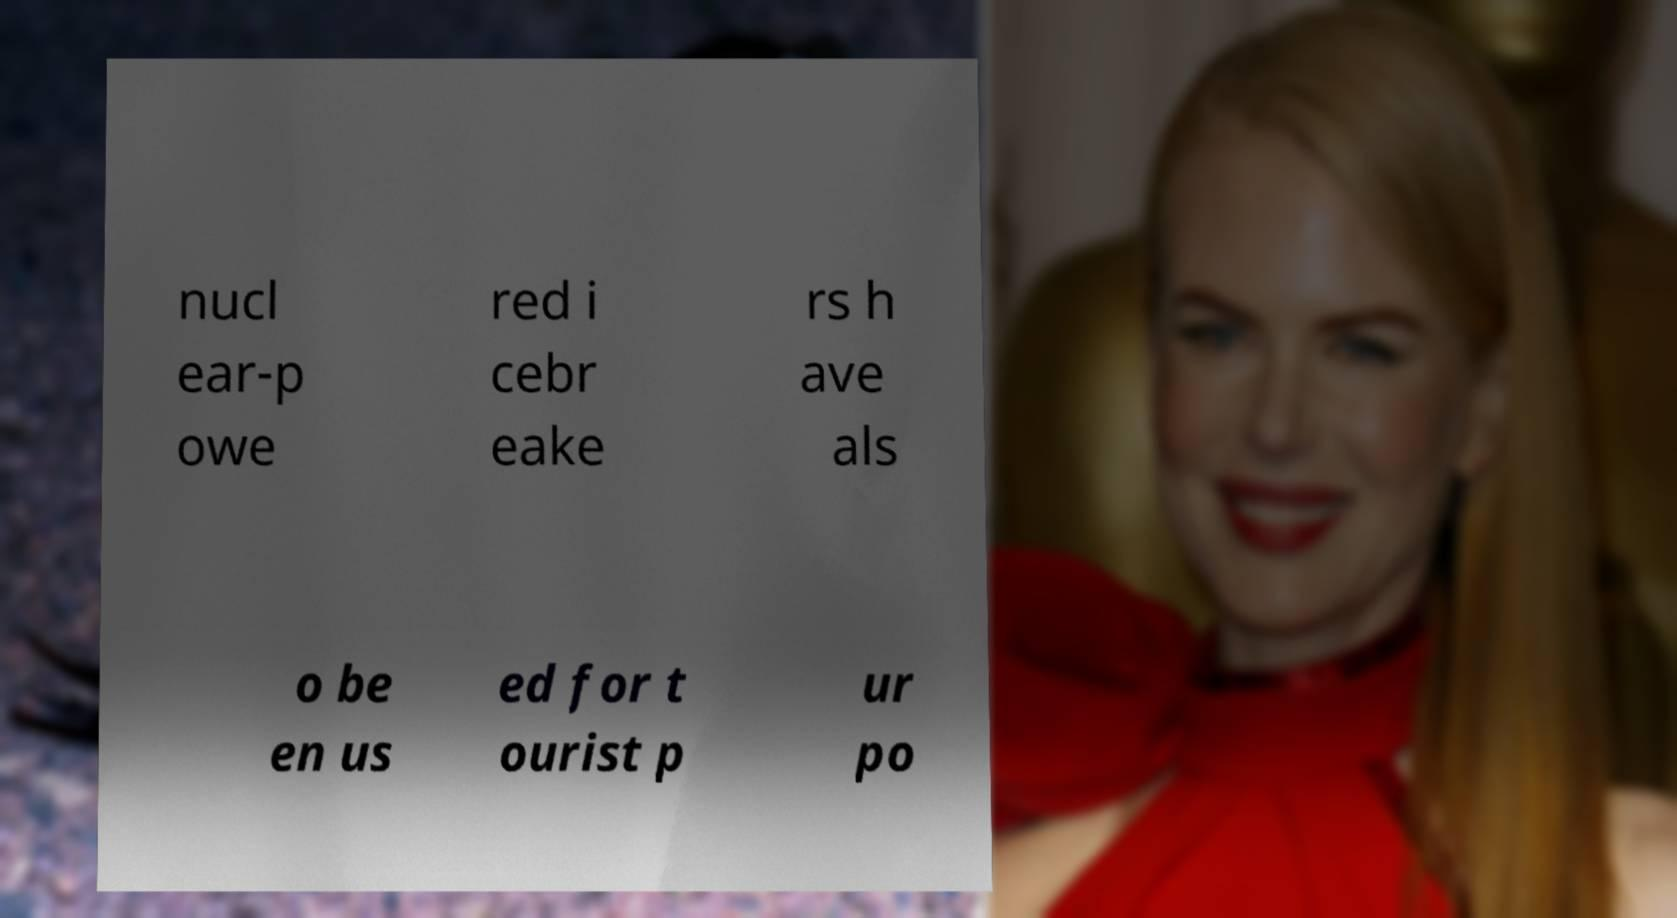Can you read and provide the text displayed in the image?This photo seems to have some interesting text. Can you extract and type it out for me? nucl ear-p owe red i cebr eake rs h ave als o be en us ed for t ourist p ur po 